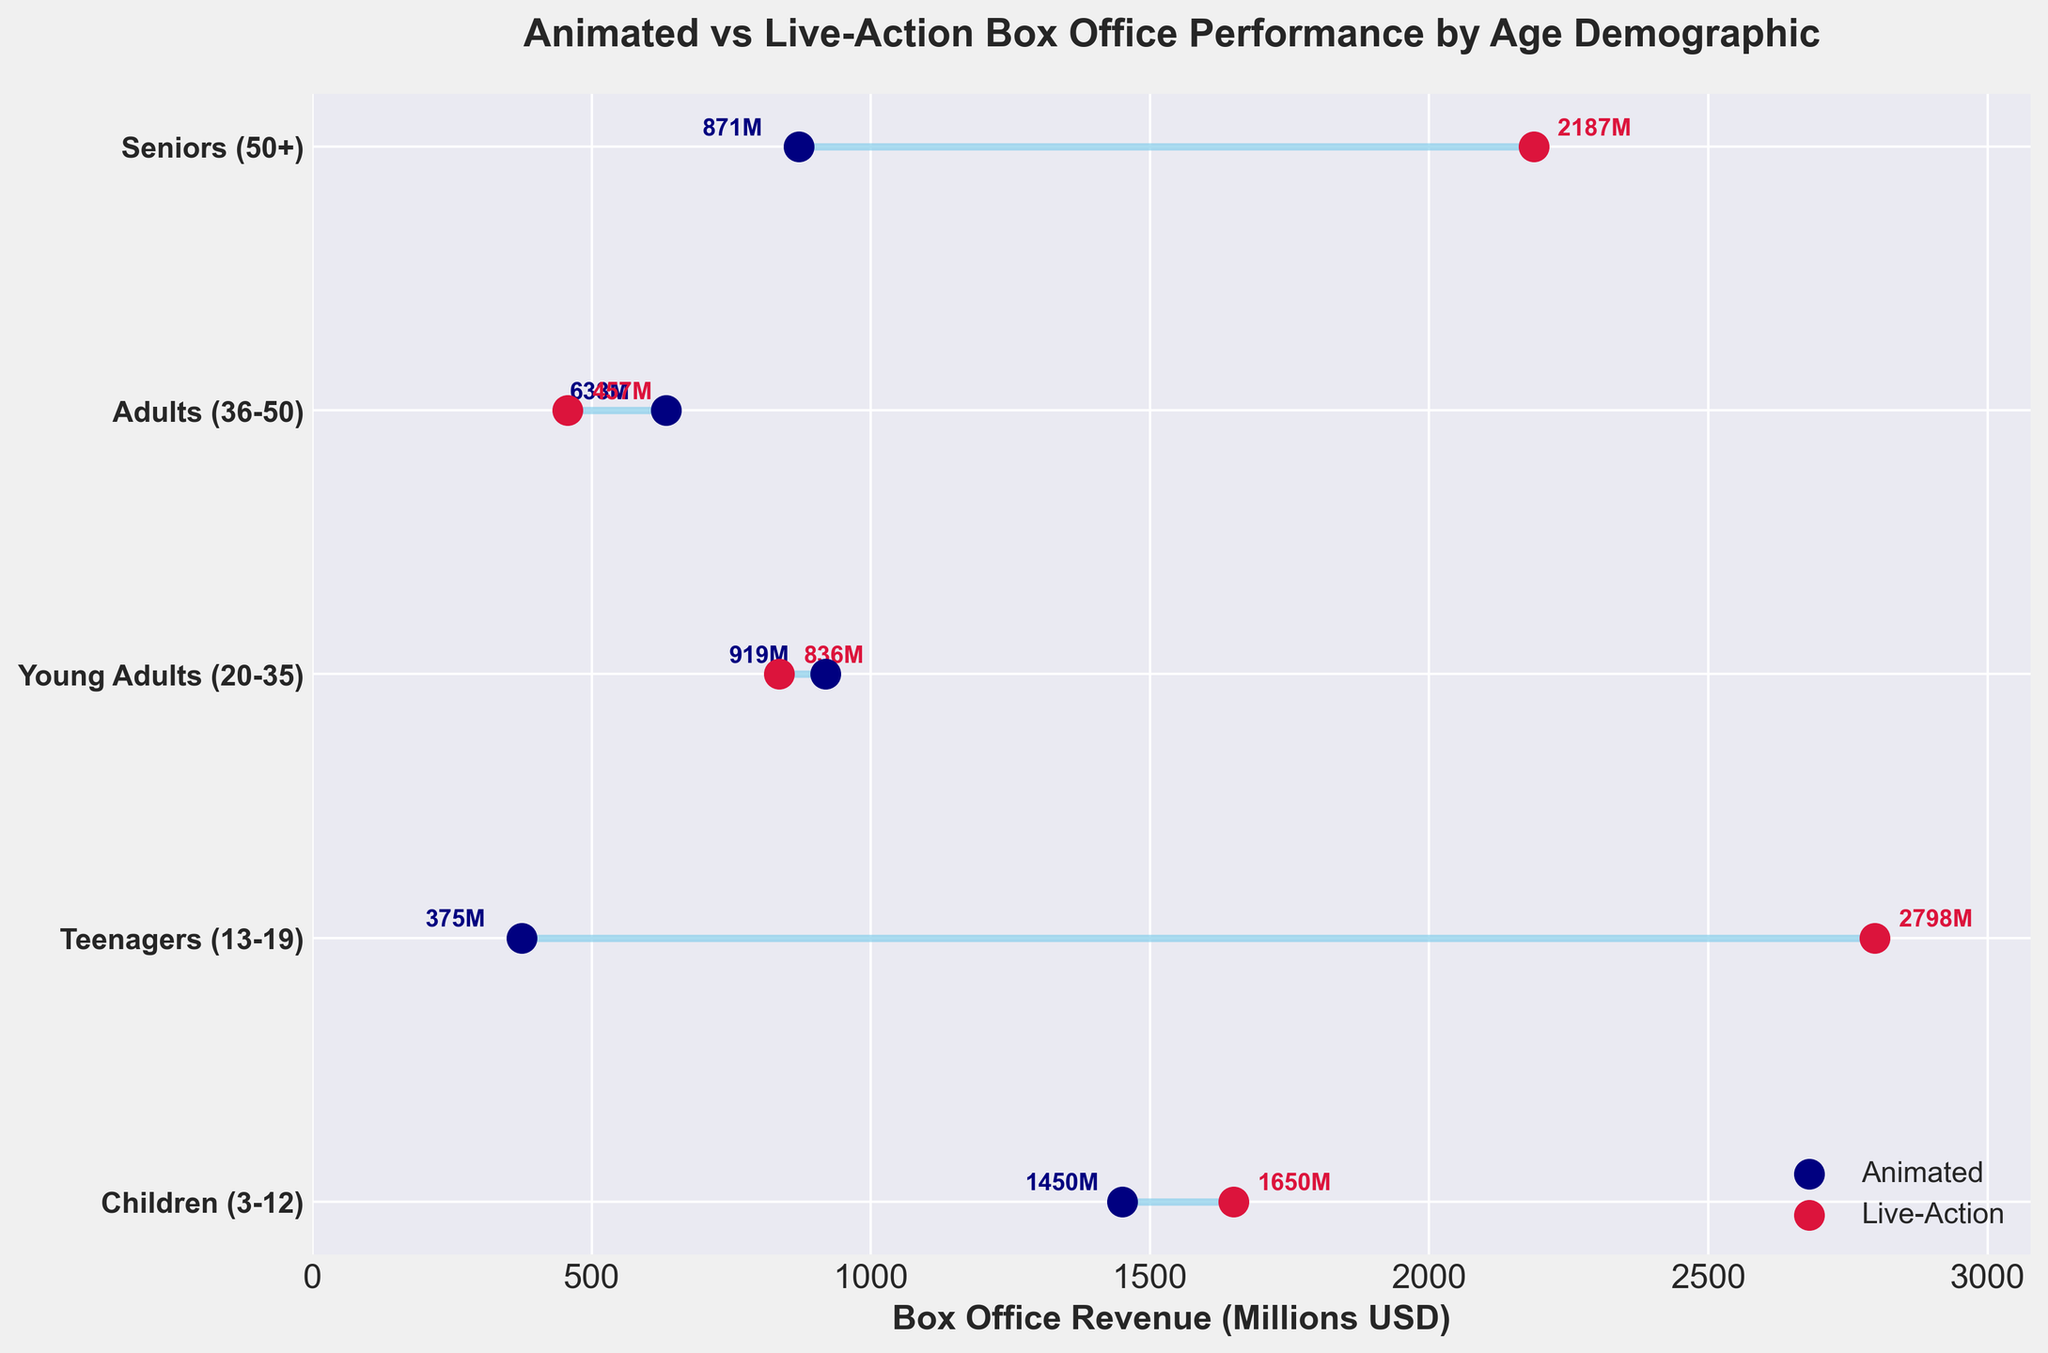What are the two movie types compared in the figure? There are two distinct types of movies shown in the dumbbell plot, represented by different colors. The blue dots corresponding to 'Animated' movies and red dots corresponding to 'Live-Action' movies.
Answer: Animated and Live-Action Which age demographic shows the largest box office difference between animated and live-action movies? To find the largest difference, one needs to calculate the absolute difference between the box office revenues of animated and live-action movies for each age demographic. The largest difference is between 'Teenagers (13-19)' with animated at 375M and live-action at 2798M, resulting in a difference of 2423M.
Answer: Teenagers (13-19) What is the box office revenue of 'Finding Nemo'? We need to look at the point associated with 'Finding Nemo' in the plot. The point sits close to the 'Seniors (50+)' row and shows a box office revenue label of 871M.
Answer: 871M How does the box office revenue of 'Inception' compare to 'Shrek 2'? Both 'Shrek 2' and 'Inception' are within the 'Young Adults (20-35)' demographic. 'Shrek 2' has a box office revenue of 919M, while 'Inception' has 836M. 'Shrek 2' has a higher revenue by a margin of 83M.
Answer: Shrek 2 is higher Which movie had the highest box office revenue among all listed? Scanning through each revenue point and label, 'Avengers: Endgame' in the 'Teenagers (13-19)' demographic has the highest box office revenue labeled as 2798M.
Answer: Avengers: Endgame What is the average box office revenue of live-action movies across all age demographics? Summing up the revenues for all live-action movies: 1650M (The Lion King) + 2798M (Avengers: Endgame) + 836M (Inception) + 457M (Gladiator) + 2187M (Titanic) equals 7928M. There are 5 live-action movies, so the average is 7928M / 5 = 1585.6M.
Answer: 1585.6M What is the median box office revenue of animated movies? Listing the box office revenues of animated movies: 1450M (Frozen 2), 375M (Spider-Man: Into the Spider-Verse), 919M (Shrek 2), 633M (The Incredibles), and 871M (Finding Nemo). Arranging in ascending order: 375M, 633M, 871M, 919M, 1450M. The median, the middle value, is 871M.
Answer: 871M What is the color used for live-action movies in the figure? By observing the dots representing live-action movies in the dumbbell plot, they are colored crimson, a shade of red.
Answer: Crimson How much higher is the box office revenue of 'Frozen 2' compared to 'The Incredibles'? The box office revenue for 'Frozen 2' (children demographic) is 1450M, and for 'The Incredibles' (adults demographic) is 633M. The difference between them is 1450M - 633M = 817M.
Answer: 817M 